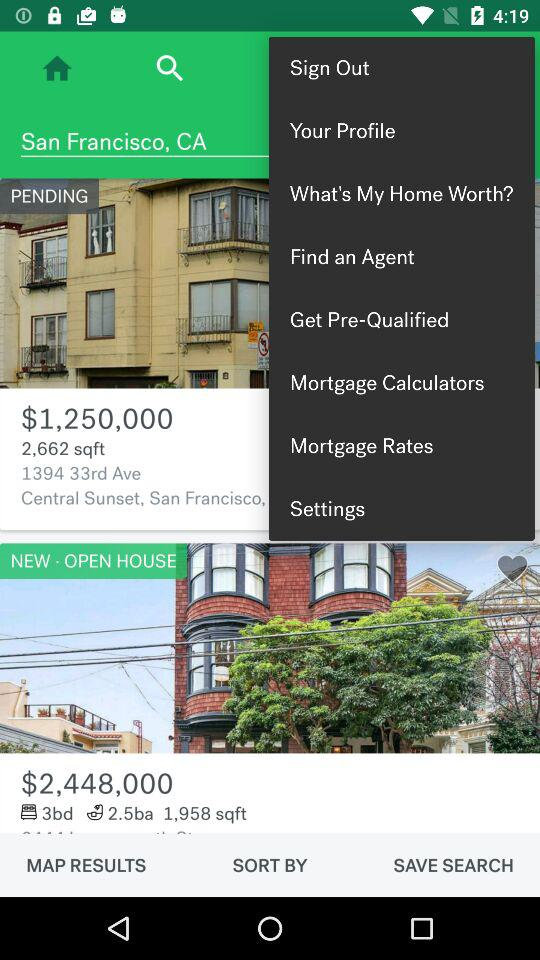What is the price of the house with a pending status? The price of the house with a pending status is $1,250,000. 